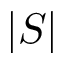Convert formula to latex. <formula><loc_0><loc_0><loc_500><loc_500>| S |</formula> 